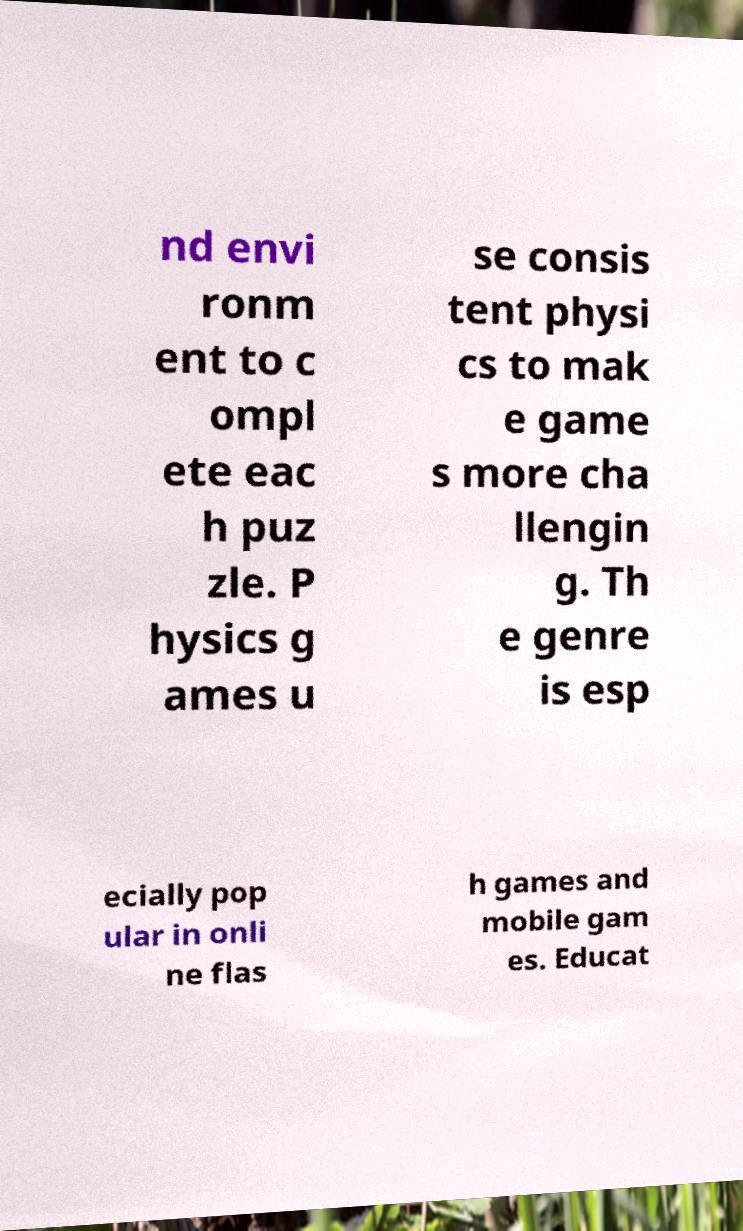I need the written content from this picture converted into text. Can you do that? nd envi ronm ent to c ompl ete eac h puz zle. P hysics g ames u se consis tent physi cs to mak e game s more cha llengin g. Th e genre is esp ecially pop ular in onli ne flas h games and mobile gam es. Educat 